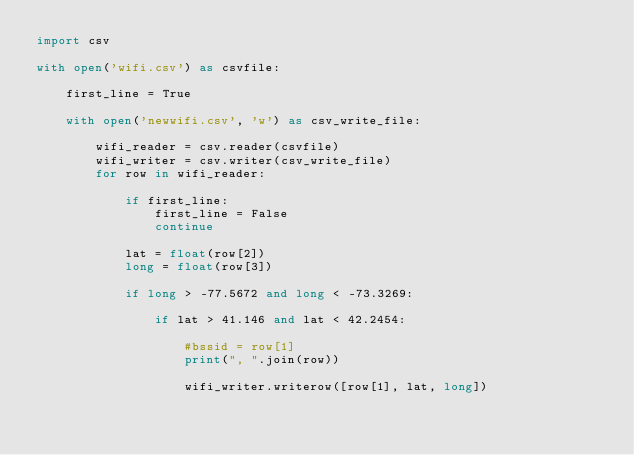<code> <loc_0><loc_0><loc_500><loc_500><_Python_>import csv

with open('wifi.csv') as csvfile:

    first_line = True

    with open('newwifi.csv', 'w') as csv_write_file:

        wifi_reader = csv.reader(csvfile)
        wifi_writer = csv.writer(csv_write_file)
        for row in wifi_reader:

            if first_line:
                first_line = False
                continue

            lat = float(row[2])
            long = float(row[3])

            if long > -77.5672 and long < -73.3269:

                if lat > 41.146 and lat < 42.2454:

                    #bssid = row[1]
                    print(", ".join(row))

                    wifi_writer.writerow([row[1], lat, long])




</code> 